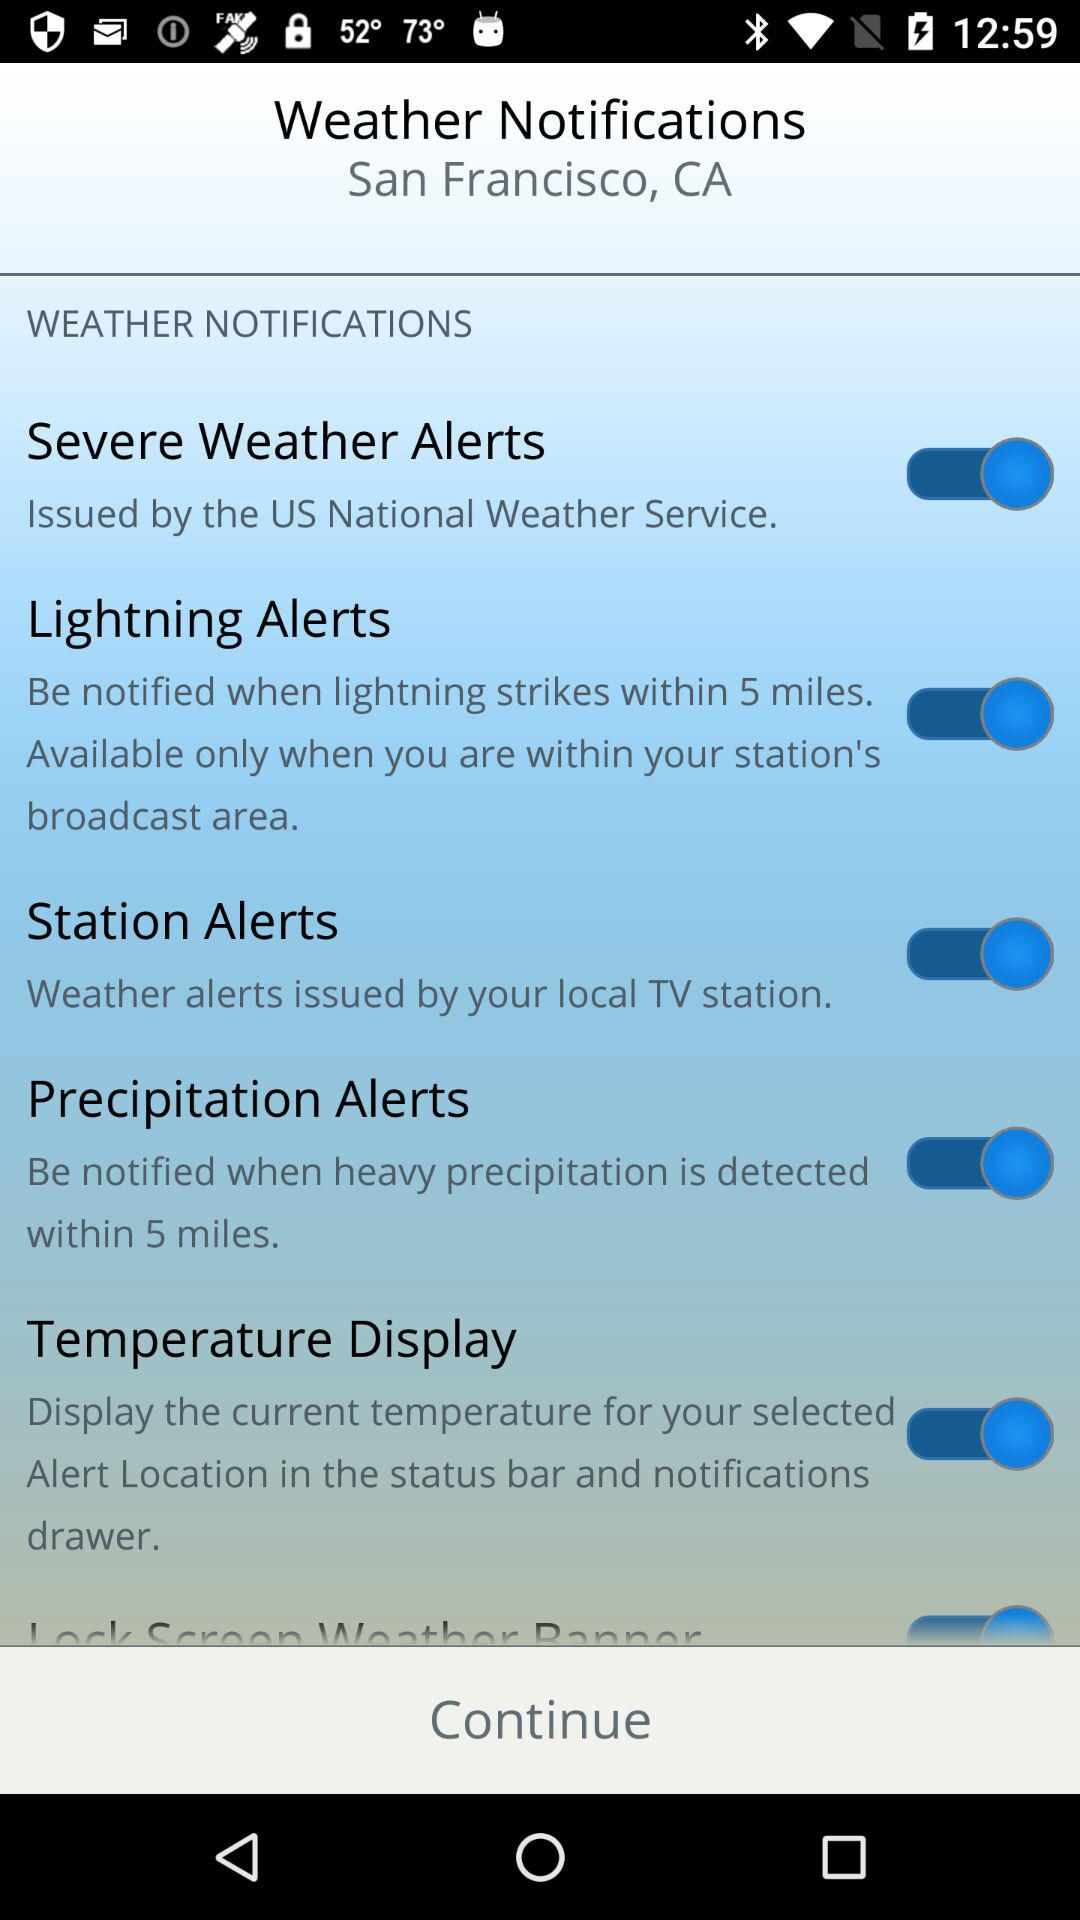What is the status of "Temperature Display"? The status is "on". 